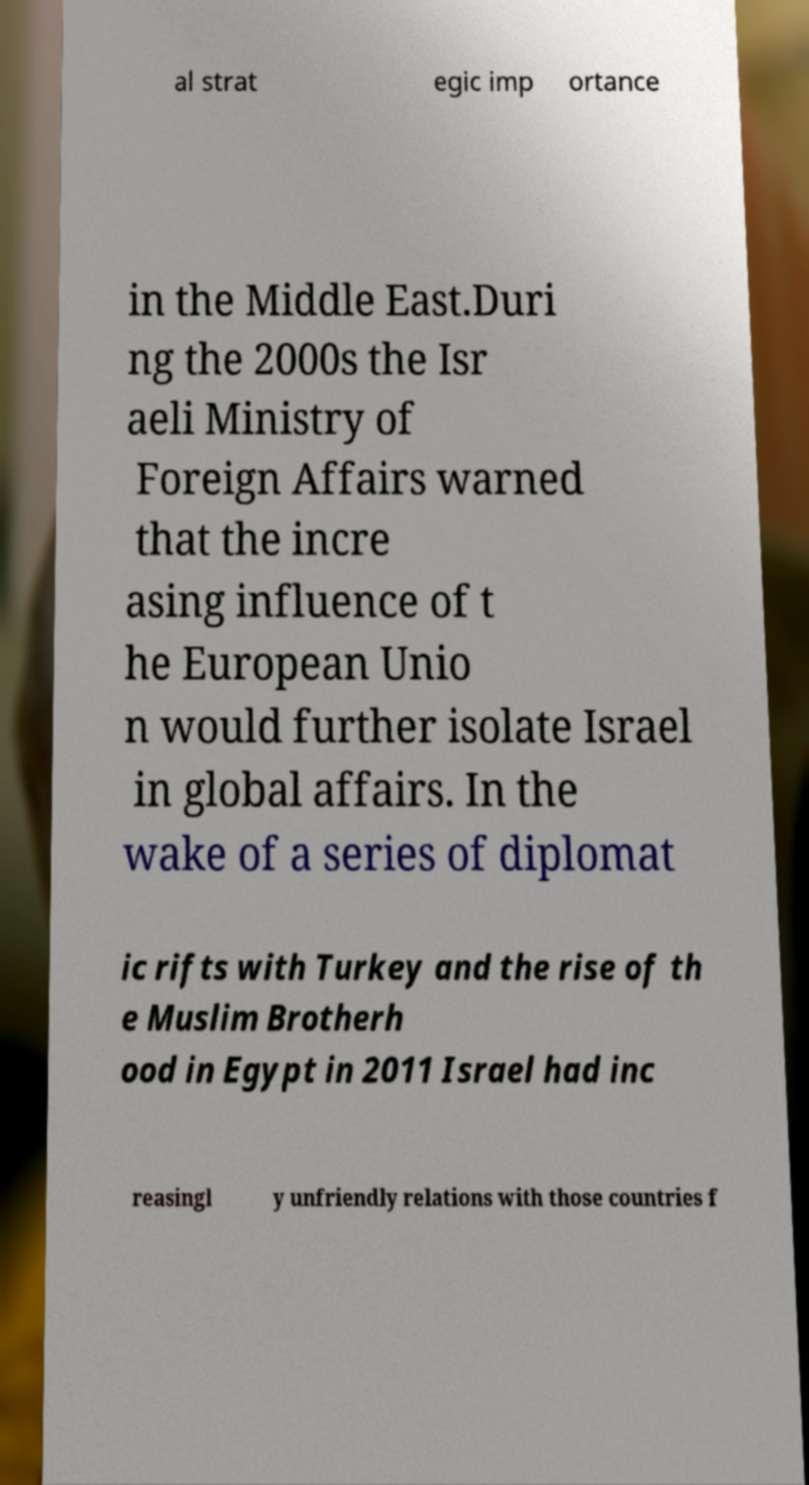What messages or text are displayed in this image? I need them in a readable, typed format. al strat egic imp ortance in the Middle East.Duri ng the 2000s the Isr aeli Ministry of Foreign Affairs warned that the incre asing influence of t he European Unio n would further isolate Israel in global affairs. In the wake of a series of diplomat ic rifts with Turkey and the rise of th e Muslim Brotherh ood in Egypt in 2011 Israel had inc reasingl y unfriendly relations with those countries f 